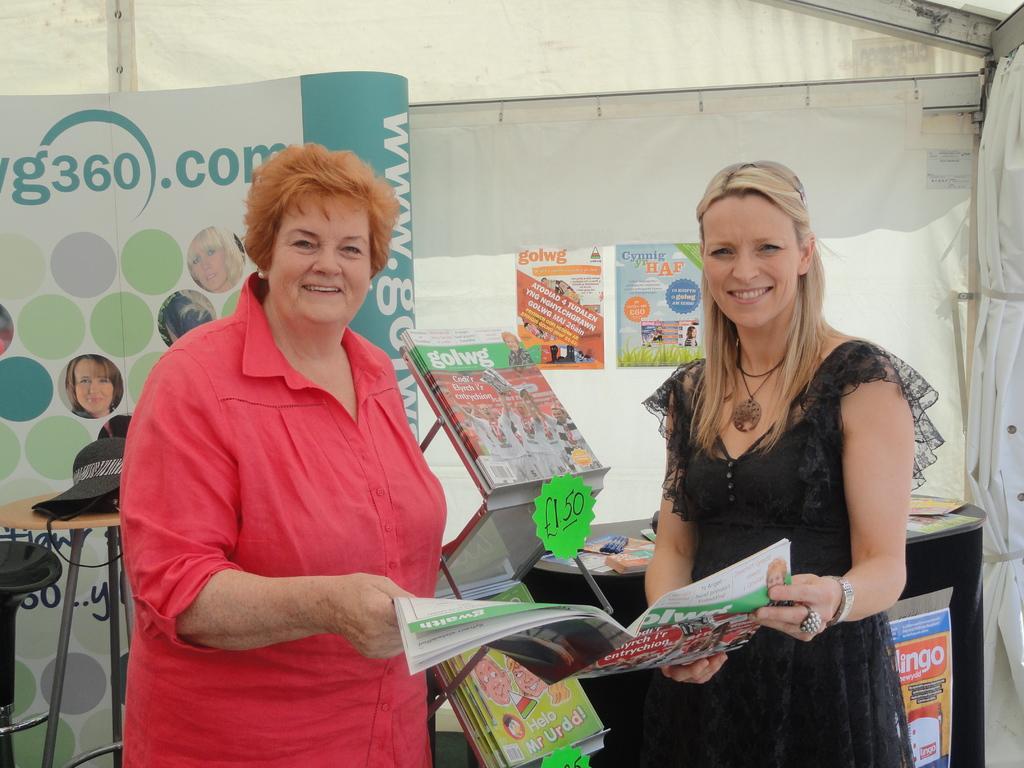In one or two sentences, can you explain what this image depicts? In this image I can see two women holding a book. On the left side I can see an object on the table. 